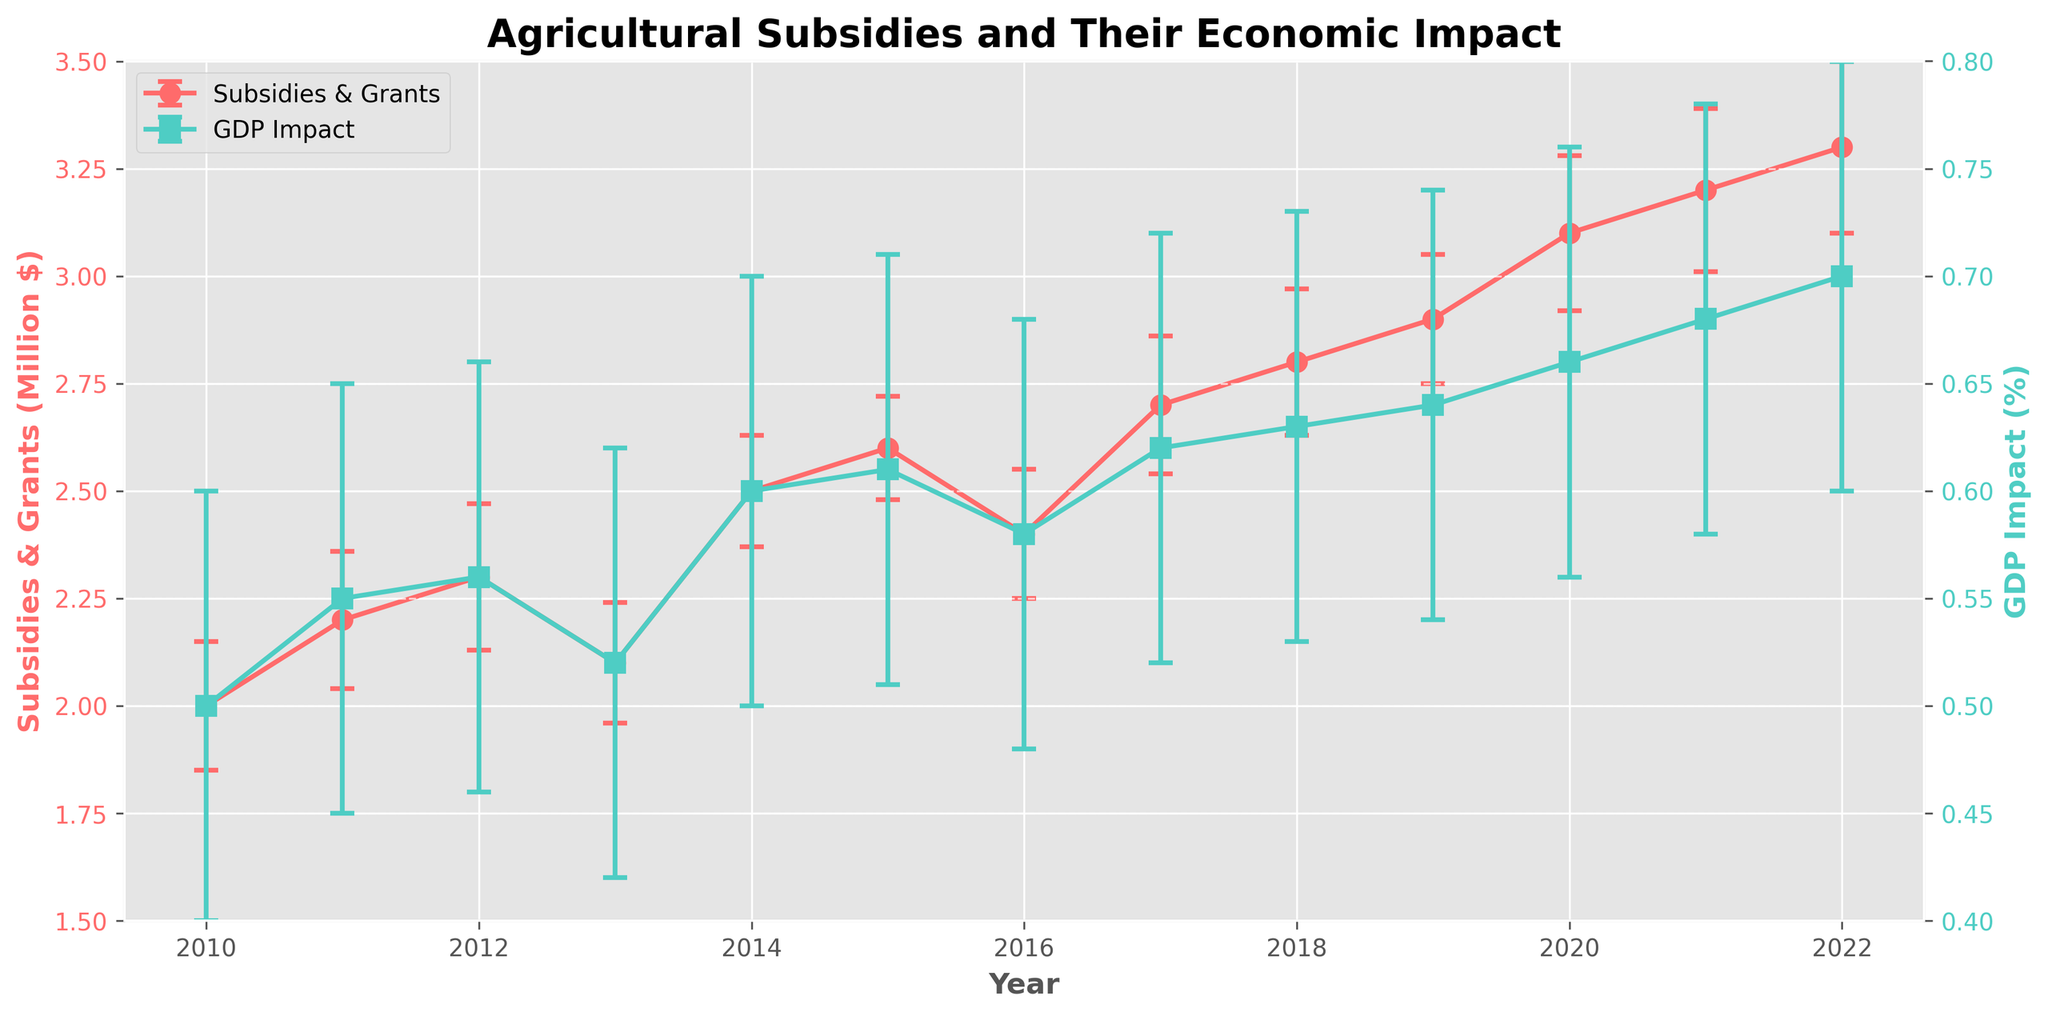What's the title of the plot? The plot's title is typically displayed prominently at the top in a larger and bold font, and it reads: "Agricultural Subsidies and Their Economic Impact".
Answer: Agricultural Subsidies and Their Economic Impact What are the two y-axes representing in the plot? By examining the labels on the y-axes, one can see that the left y-axis represents "Subsidies & Grants (Million $)" and the right y-axis represents "GDP Impact (%)".
Answer: Subsidies & Grants (Million $) and GDP Impact (%) Between which years did the subsidies & grants see the highest increase? To determine this, calculate the difference in subsidies & grants for consecutive years and identify the maximum increase. The highest increase is from 2019 to 2020, where it goes from 2900000 to 3100000 (200000 increase).
Answer: 2019 to 2020 What is the general trend observed in the GDP impact percentage over the years? Observation of the GDP impact line shows a consistent upward trend from 2010 to 2022. The impact percentage increases steadily over the period.
Answer: Increasing Between which years did the GDP impact percentage experience the least change? To find this, calculate the difference in GDP impact for consecutive years. From 2011 to 2012, it changes from 0.55 to 0.56, which is the least change (0.01 difference).
Answer: 2011 to 2012 What was the error margin for subsidies & grants in the year 2022? Referring to the error bars and the corresponding data point for 2022, the error margin for subsidies & grants is 200000.
Answer: 200000 From 2016 to 2017, how did the values for subsidies & grants and GDP impact change? Compare the values from 2016 and 2017: Subsidies & grants increased from 2400000 to 2700000, while GDP impact rose from 0.58 to 0.62. Therefore, subsidies & grants increased by 300000, and GDP impact increased by 0.04.
Answer: Subsidies & grants: +300000, GDP impact: +0.04 Which year had the highest GDP impact percentage and what was the value? By looking at the maximum point on the GDP impact line, the highest GDP impact percentage occurs in 2022 with a value of 0.7.
Answer: 2022, 0.7 Were there any years where the subsidies & grants decreased compared to the previous year? By comparing each year's subsidies & grants value to the previous year's, we observe a decrease from 2012 to 2013 (2300000 to 2100000) and from 2015 to 2016 (2600000 to 2400000).
Answer: 2012 to 2013 and 2015 to 2016 How did the economic impact in terms of GDP change alongside the increase in subsidies & grants from 2020 to 2022? From 2020 to 2022, subsidies & grants increased from 3100000 to 3300000, and the GDP impact increased from 0.66 to 0.7. Both subsidies & grants and the GDP impact show an upward trend in this period.
Answer: Both increased 